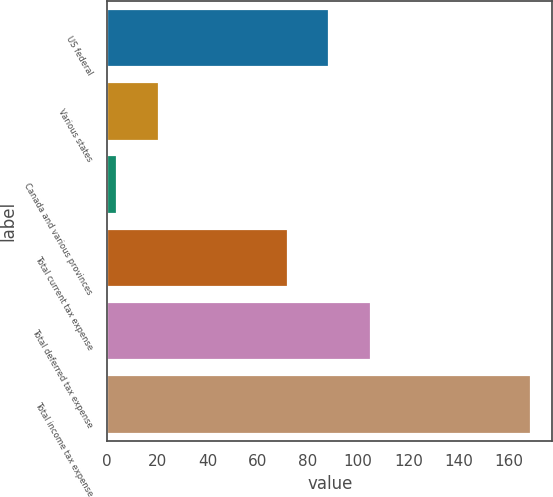<chart> <loc_0><loc_0><loc_500><loc_500><bar_chart><fcel>US federal<fcel>Various states<fcel>Canada and various provinces<fcel>Total current tax expense<fcel>Total deferred tax expense<fcel>Total income tax expense<nl><fcel>88.5<fcel>20.5<fcel>4<fcel>72<fcel>105<fcel>169<nl></chart> 